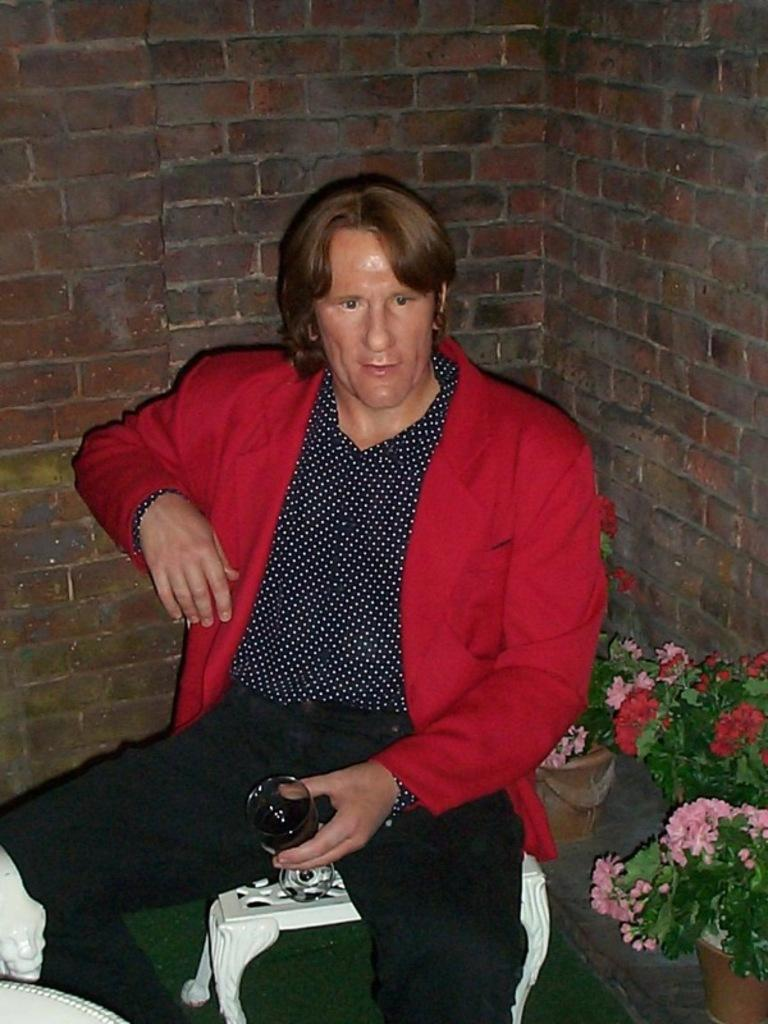What type of wall can be seen in the background of the image? There is a wall with bricks in the background. What is the man in the image doing? The man is sitting on a chair. What color is the jacket the man is wearing? The man is wearing a red jacket. What is the man holding in his hand? The man is holding a glass of drink in his hand. Can you describe any other objects in the image? There is a flower pot in the image. How many geese are walking in front of the man in the image? There are no geese present in the image. What type of peace symbol can be seen on the wall in the image? There is no peace symbol present on the wall in the image; it is a brick wall. 